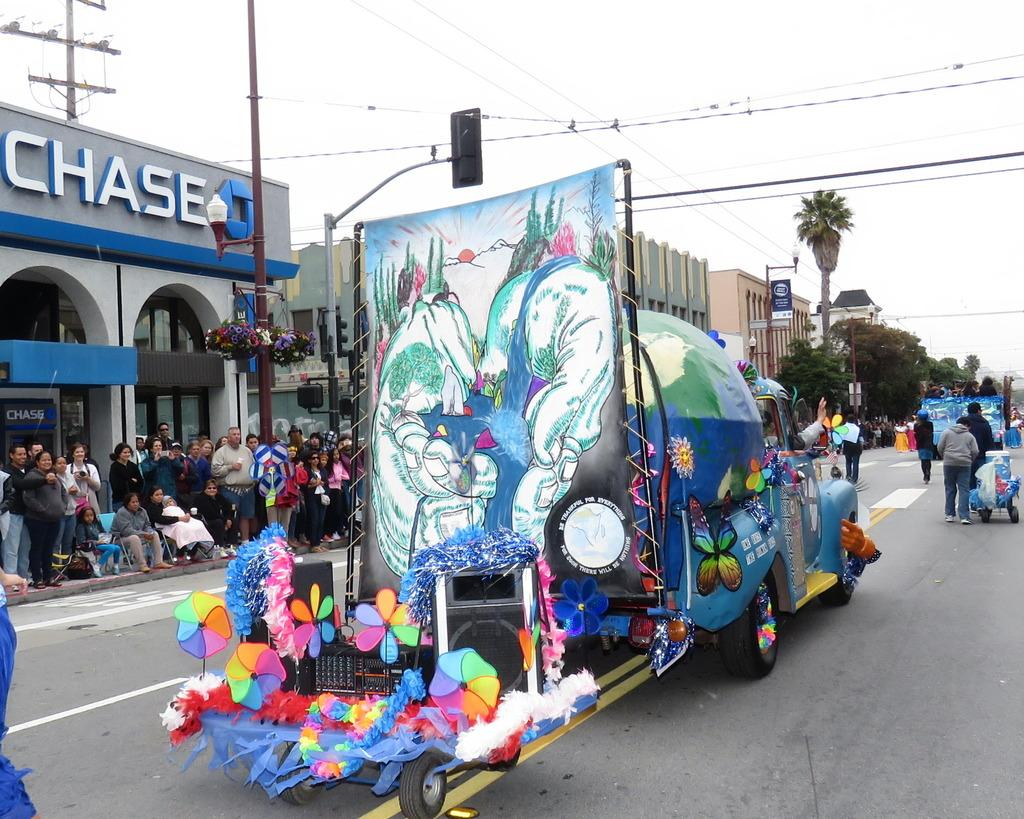<image>
Share a concise interpretation of the image provided. A parade passes in front of a CHASE brand bank. 